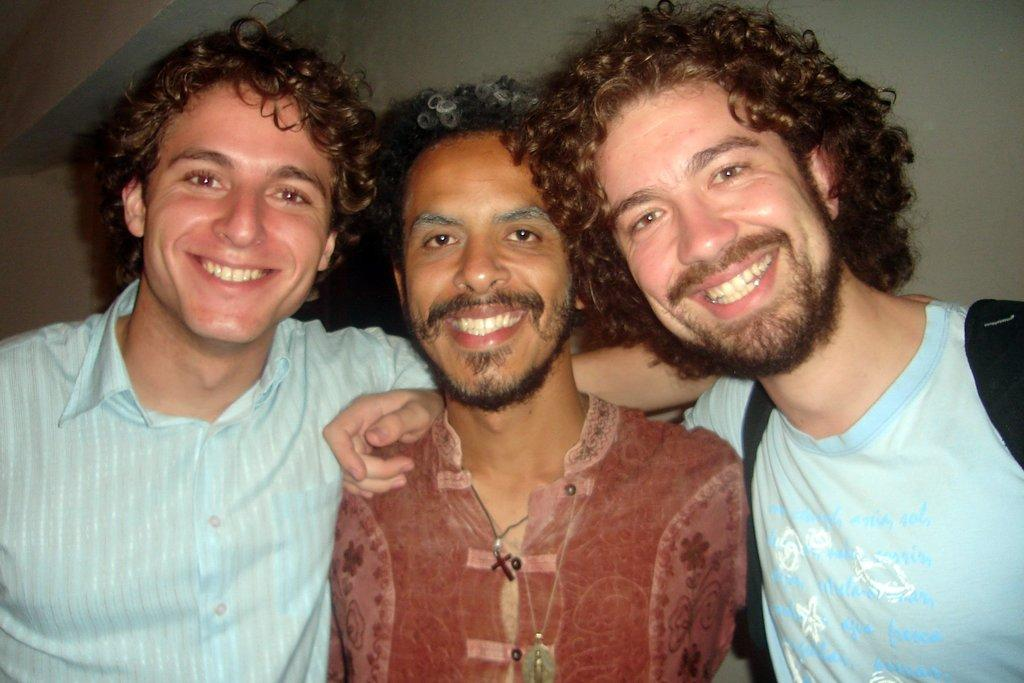How many men are in the image? There are three men standing in the image. What are the men wearing? The three men are wearing blue shirts. Are there any other people in the image? Yes, there is a person wearing a brown shirt. What can be seen in the background of the image? There is a wall in the background of the image. Can you see a toad hopping near the wall in the image? No, there is no toad present in the image. What type of curtain is hanging from the wall in the image? There is no curtain visible in the image; only a wall is present in the background. 